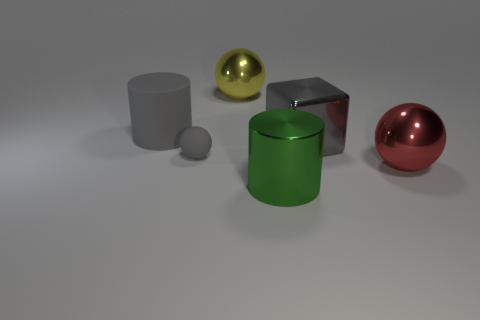There is a large cylinder that is the same color as the tiny matte object; what is its material?
Give a very brief answer. Rubber. Are there any spheres that have the same color as the shiny block?
Provide a succinct answer. Yes. There is a cylinder that is right of the big cylinder on the left side of the big green object; are there any large gray matte cylinders on the right side of it?
Ensure brevity in your answer.  No. What number of other objects are there of the same shape as the small rubber object?
Make the answer very short. 2. There is a rubber thing to the right of the gray object behind the big gray thing that is on the right side of the large yellow shiny object; what is its color?
Offer a very short reply. Gray. What number of big yellow metallic balls are there?
Ensure brevity in your answer.  1. How many tiny objects are either red metallic spheres or purple matte objects?
Offer a terse response. 0. The matte object that is the same size as the shiny cube is what shape?
Ensure brevity in your answer.  Cylinder. Is there anything else that is the same size as the gray ball?
Make the answer very short. No. What material is the big gray thing on the left side of the big gray object that is to the right of the tiny rubber ball made of?
Make the answer very short. Rubber. 